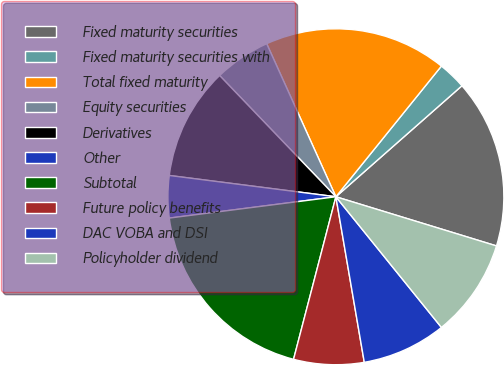Convert chart. <chart><loc_0><loc_0><loc_500><loc_500><pie_chart><fcel>Fixed maturity securities<fcel>Fixed maturity securities with<fcel>Total fixed maturity<fcel>Equity securities<fcel>Derivatives<fcel>Other<fcel>Subtotal<fcel>Future policy benefits<fcel>DAC VOBA and DSI<fcel>Policyholder dividend<nl><fcel>16.22%<fcel>2.7%<fcel>17.57%<fcel>5.41%<fcel>10.81%<fcel>4.05%<fcel>18.92%<fcel>6.76%<fcel>8.11%<fcel>9.46%<nl></chart> 